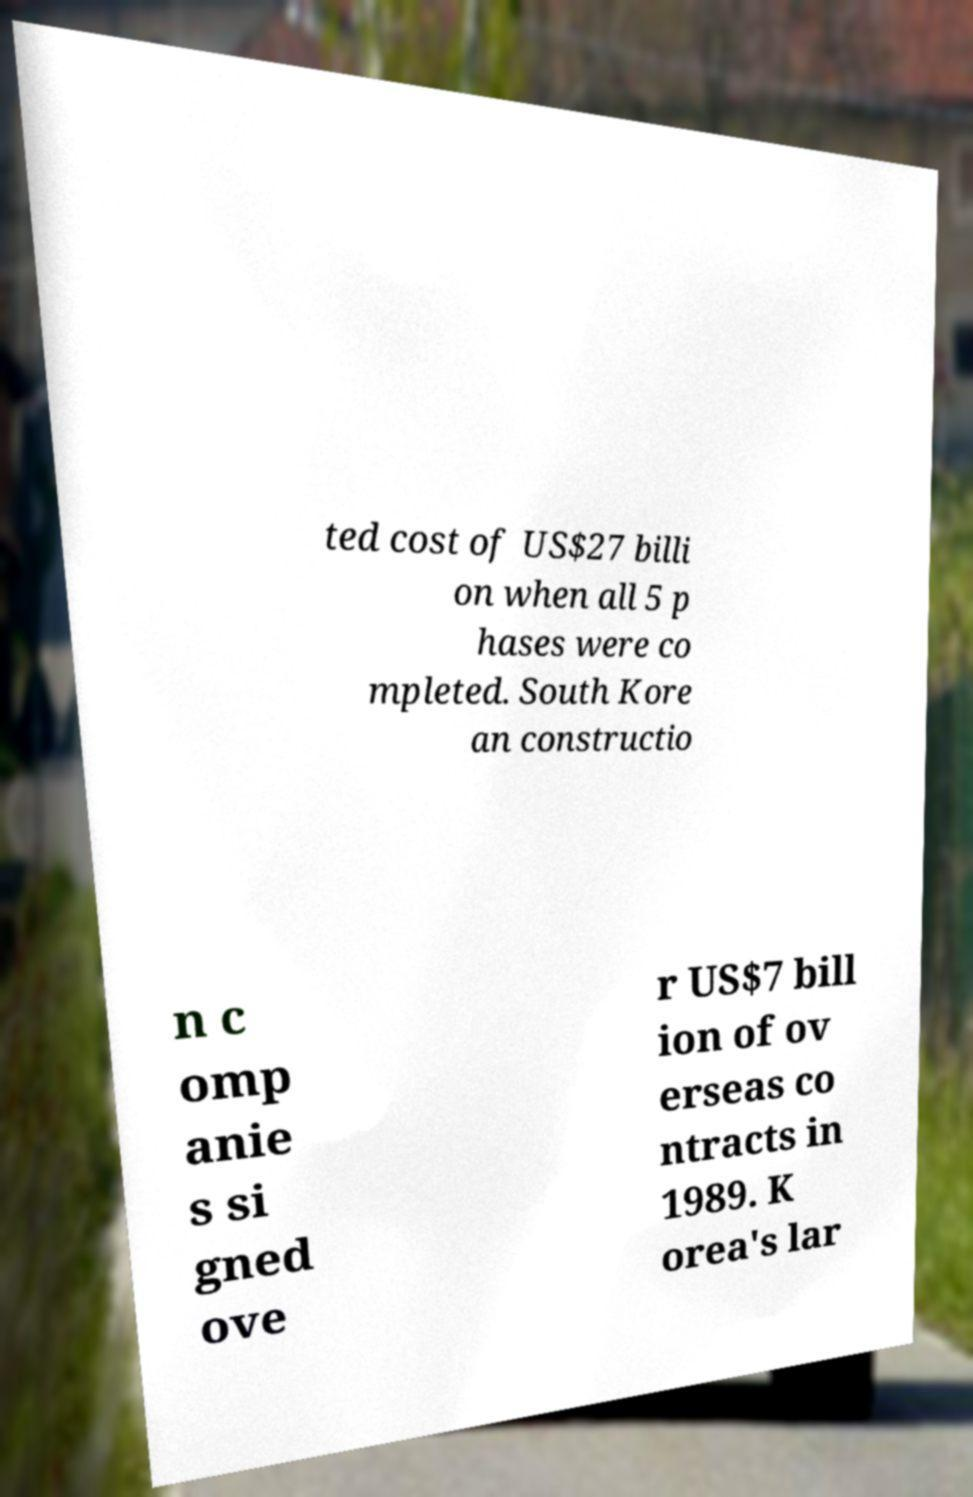Can you read and provide the text displayed in the image?This photo seems to have some interesting text. Can you extract and type it out for me? ted cost of US$27 billi on when all 5 p hases were co mpleted. South Kore an constructio n c omp anie s si gned ove r US$7 bill ion of ov erseas co ntracts in 1989. K orea's lar 